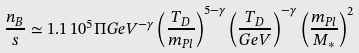Convert formula to latex. <formula><loc_0><loc_0><loc_500><loc_500>\frac { n _ { B } } { s } \simeq 1 . 1 \, 1 0 ^ { 5 } \Pi G e V ^ { - \gamma } \left ( \frac { T _ { D } } { m _ { P l } } \right ) ^ { 5 - \gamma } \left ( \frac { T _ { D } } { G e V } \right ) ^ { - \gamma } \left ( \frac { m _ { P l } } { M _ { * } } \right ) ^ { 2 }</formula> 